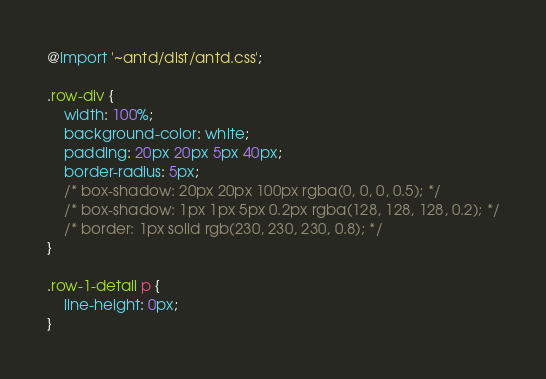<code> <loc_0><loc_0><loc_500><loc_500><_CSS_>@import '~antd/dist/antd.css';

.row-div {
    width: 100%;
    background-color: white;
    padding: 20px 20px 5px 40px;
    border-radius: 5px;
    /* box-shadow: 20px 20px 100px rgba(0, 0, 0, 0.5); */
    /* box-shadow: 1px 1px 5px 0.2px rgba(128, 128, 128, 0.2); */
    /* border: 1px solid rgb(230, 230, 230, 0.8); */
}

.row-1-detail p {
    line-height: 0px;
}
</code> 